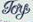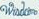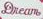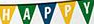What words can you see in these images in sequence, separated by a semicolon? Toy; ####; Dream; HAPPY 